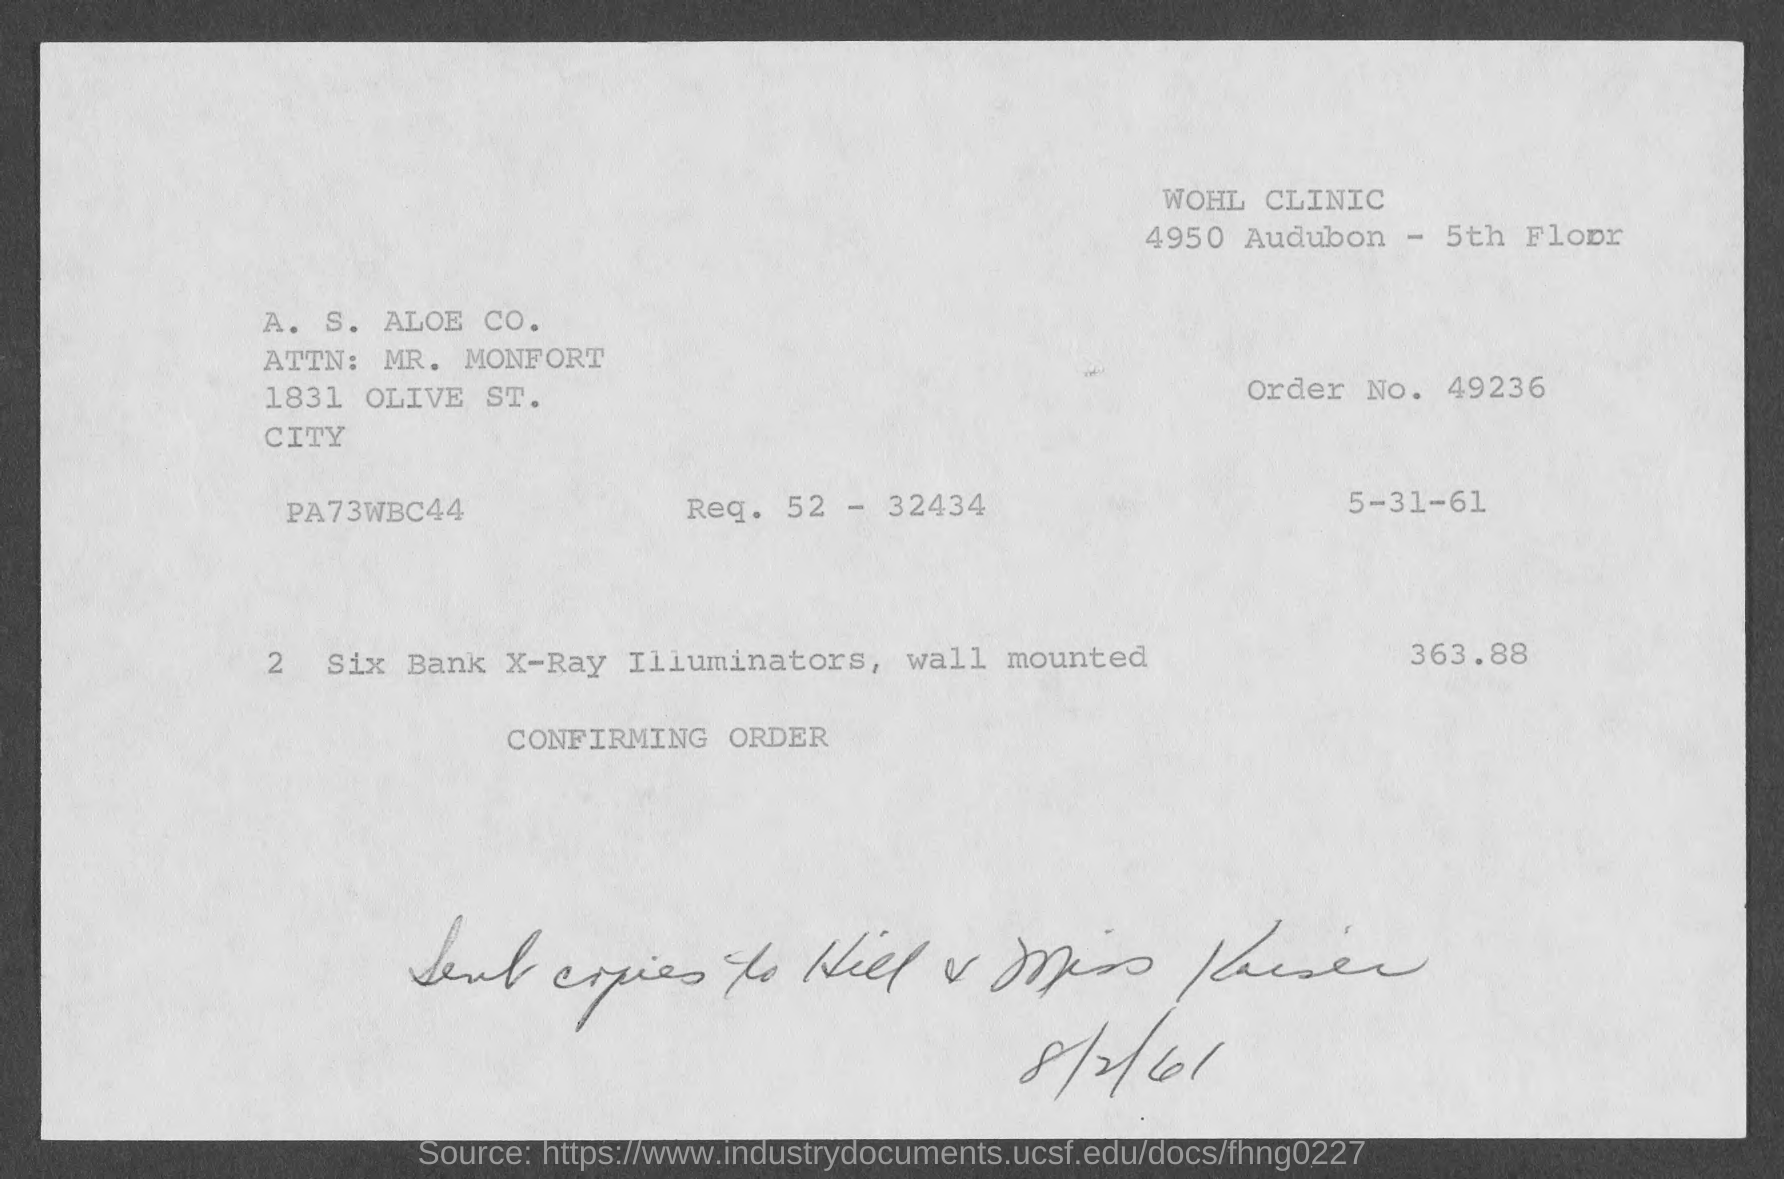What is the Order No. ?
Give a very brief answer. 49236. In Which floor the clinic is?
Offer a terse response. 5th. What is the price of the bill ?
Offer a very short reply. 363.88. 